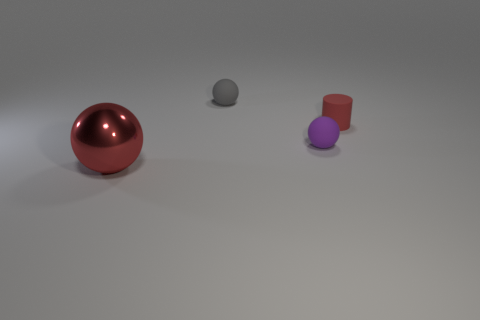Add 4 matte spheres. How many objects exist? 8 Subtract all cylinders. How many objects are left? 3 Subtract all tiny cylinders. Subtract all small purple objects. How many objects are left? 2 Add 1 large red metallic balls. How many large red metallic balls are left? 2 Add 3 large yellow rubber things. How many large yellow rubber things exist? 3 Subtract 0 blue cylinders. How many objects are left? 4 